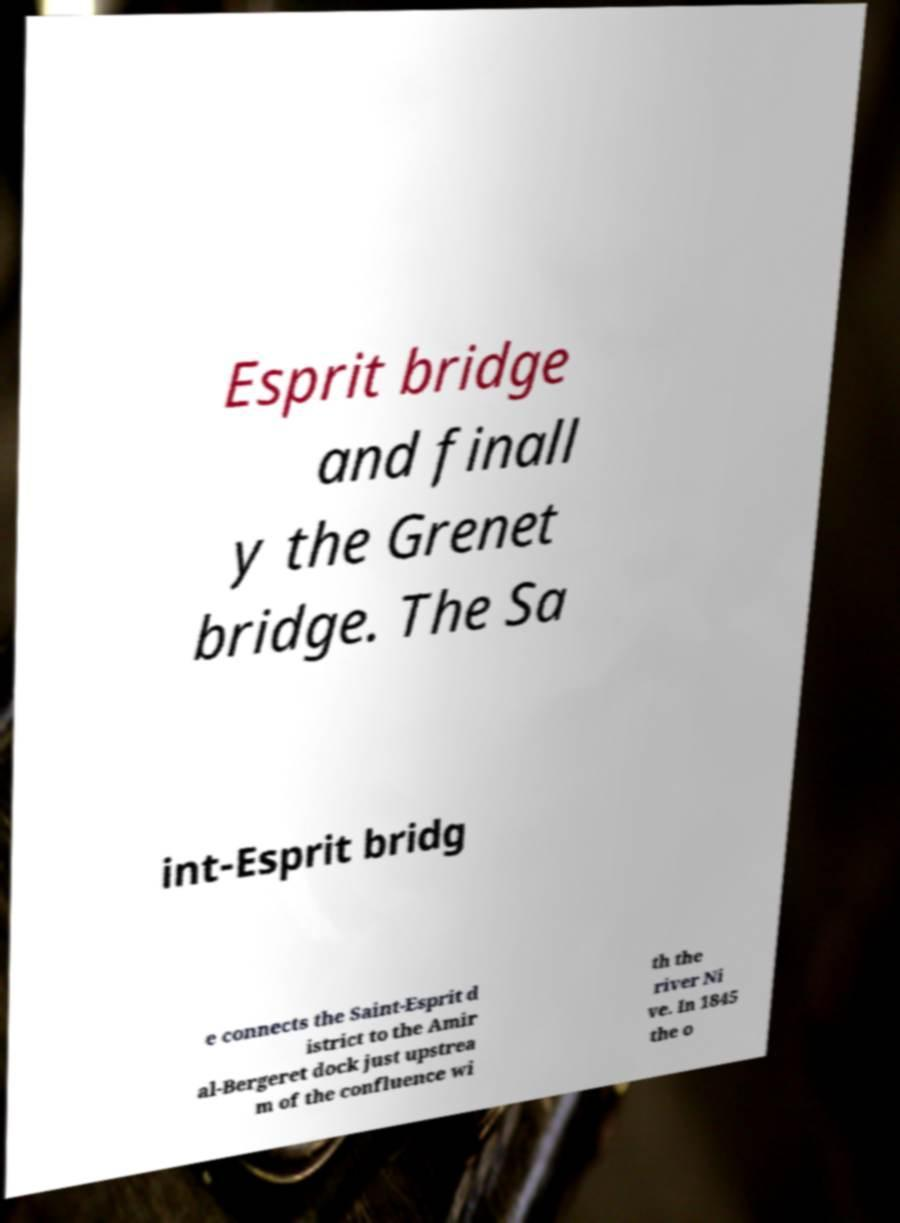What messages or text are displayed in this image? I need them in a readable, typed format. Esprit bridge and finall y the Grenet bridge. The Sa int-Esprit bridg e connects the Saint-Esprit d istrict to the Amir al-Bergeret dock just upstrea m of the confluence wi th the river Ni ve. In 1845 the o 